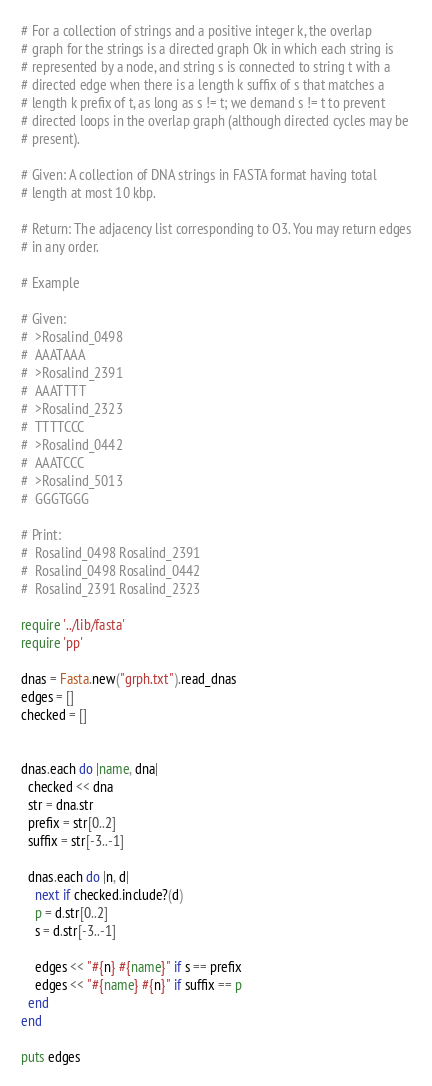<code> <loc_0><loc_0><loc_500><loc_500><_Ruby_># For a collection of strings and a positive integer k, the overlap
# graph for the strings is a directed graph Ok in which each string is
# represented by a node, and string s is connected to string t with a
# directed edge when there is a length k suffix of s that matches a
# length k prefix of t, as long as s != t; we demand s != t to prevent
# directed loops in the overlap graph (although directed cycles may be
# present).

# Given: A collection of DNA strings in FASTA format having total
# length at most 10 kbp.

# Return: The adjacency list corresponding to O3. You may return edges
# in any order.

# Example

# Given:
#  >Rosalind_0498
#  AAATAAA
#  >Rosalind_2391
#  AAATTTT
#  >Rosalind_2323
#  TTTTCCC
#  >Rosalind_0442
#  AAATCCC
#  >Rosalind_5013
#  GGGTGGG

# Print:
#  Rosalind_0498 Rosalind_2391
#  Rosalind_0498 Rosalind_0442
#  Rosalind_2391 Rosalind_2323

require '../lib/fasta'
require 'pp'

dnas = Fasta.new("grph.txt").read_dnas
edges = []
checked = []


dnas.each do |name, dna|
  checked << dna
  str = dna.str
  prefix = str[0..2]
  suffix = str[-3..-1]

  dnas.each do |n, d|
    next if checked.include?(d)
    p = d.str[0..2]
    s = d.str[-3..-1]

    edges << "#{n} #{name}" if s == prefix
    edges << "#{name} #{n}" if suffix == p
  end
end

puts edges
</code> 